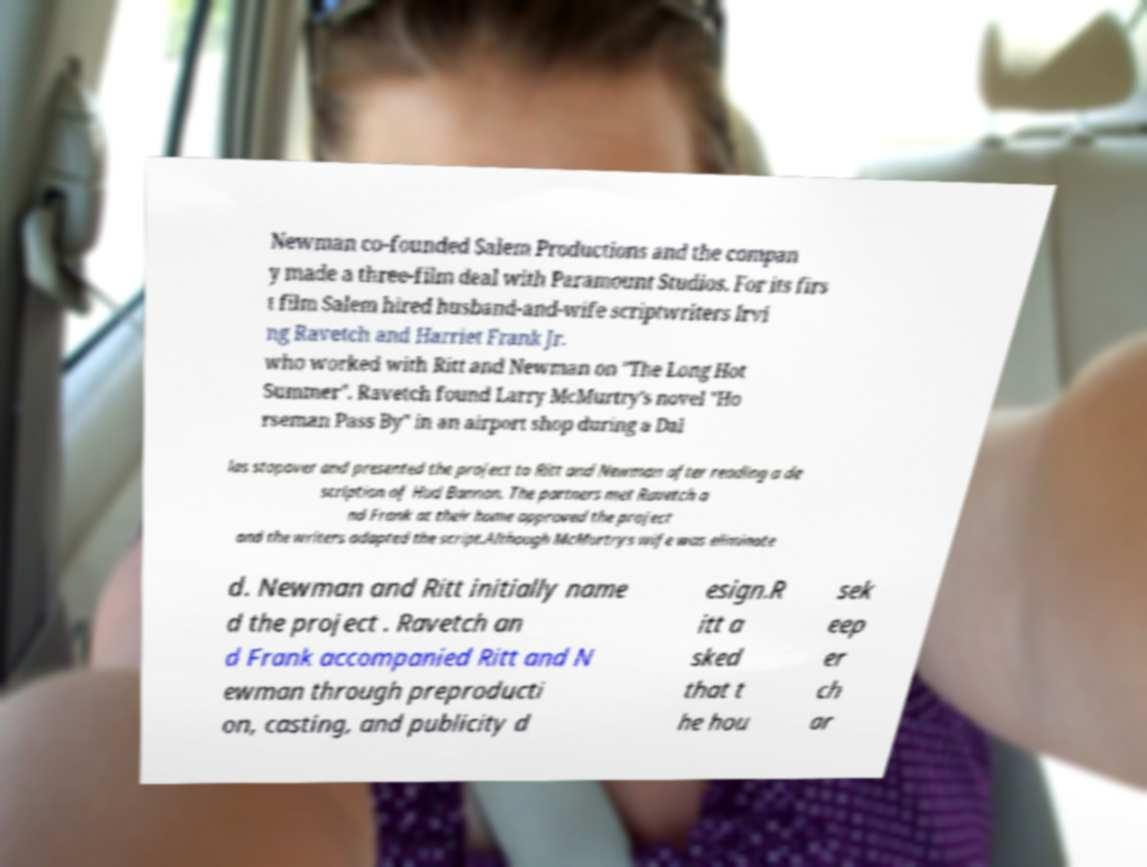Can you read and provide the text displayed in the image?This photo seems to have some interesting text. Can you extract and type it out for me? Newman co-founded Salem Productions and the compan y made a three-film deal with Paramount Studios. For its firs t film Salem hired husband-and-wife scriptwriters Irvi ng Ravetch and Harriet Frank Jr. who worked with Ritt and Newman on "The Long Hot Summer". Ravetch found Larry McMurtry's novel "Ho rseman Pass By" in an airport shop during a Dal las stopover and presented the project to Ritt and Newman after reading a de scription of Hud Bannon. The partners met Ravetch a nd Frank at their home approved the project and the writers adapted the script.Although McMurtrys wife was eliminate d. Newman and Ritt initially name d the project . Ravetch an d Frank accompanied Ritt and N ewman through preproducti on, casting, and publicity d esign.R itt a sked that t he hou sek eep er ch ar 